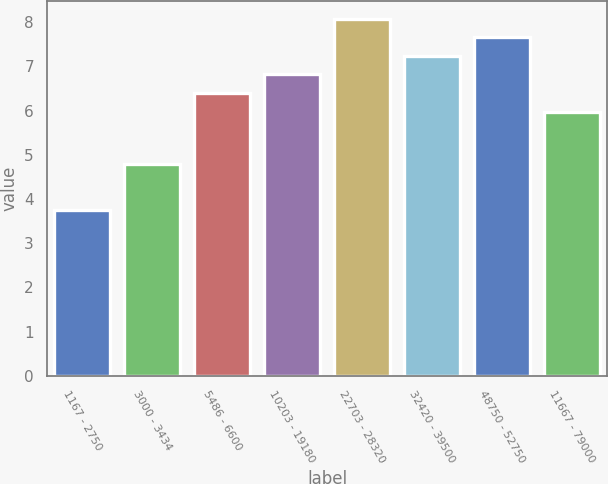Convert chart. <chart><loc_0><loc_0><loc_500><loc_500><bar_chart><fcel>1167 - 2750<fcel>3000 - 3434<fcel>5486 - 6600<fcel>10203 - 19180<fcel>22703 - 28320<fcel>32420 - 39500<fcel>48750 - 52750<fcel>11667 - 79000<nl><fcel>3.74<fcel>4.8<fcel>6.4<fcel>6.82<fcel>8.08<fcel>7.24<fcel>7.66<fcel>5.98<nl></chart> 